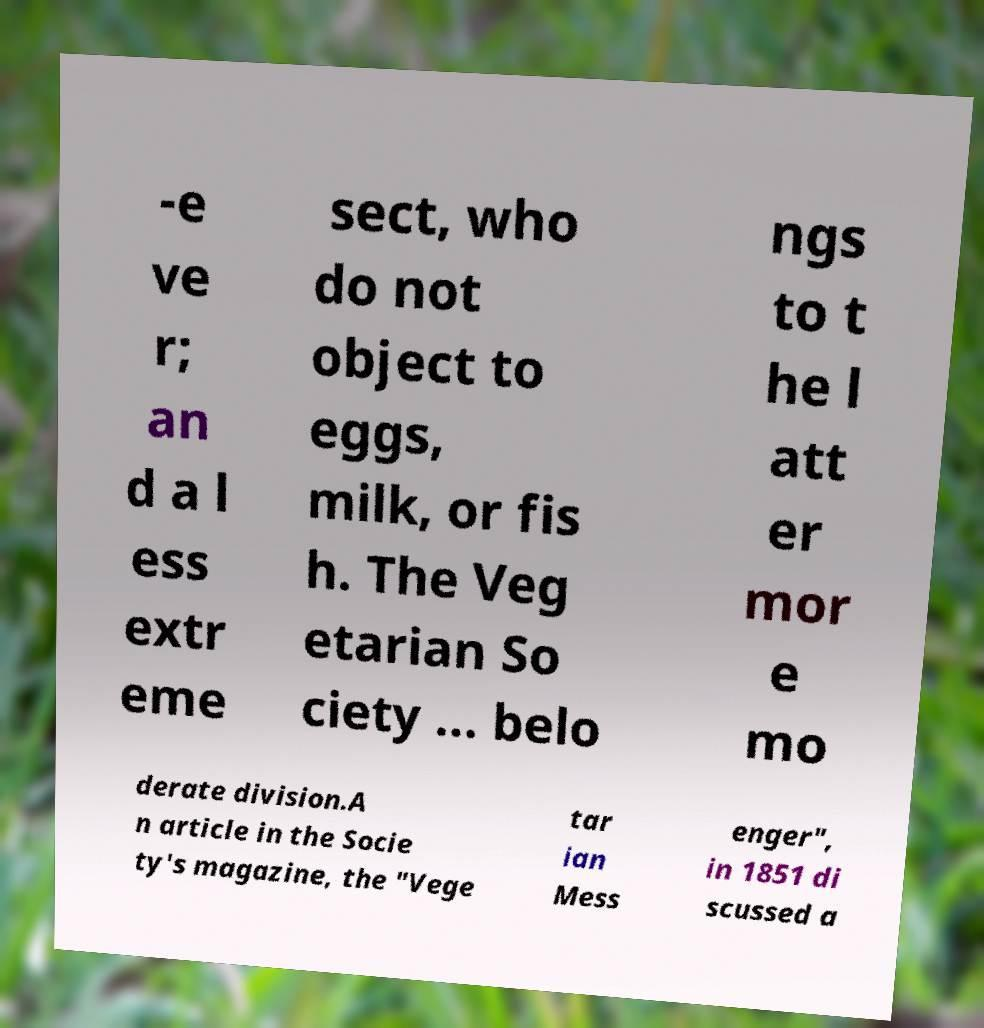Please read and relay the text visible in this image. What does it say? -e ve r; an d a l ess extr eme sect, who do not object to eggs, milk, or fis h. The Veg etarian So ciety ... belo ngs to t he l att er mor e mo derate division.A n article in the Socie ty's magazine, the "Vege tar ian Mess enger", in 1851 di scussed a 